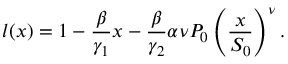<formula> <loc_0><loc_0><loc_500><loc_500>l ( x ) = 1 - \frac { \beta } { \gamma _ { 1 } } x - \frac { \beta } { \gamma _ { 2 } } \alpha \nu P _ { 0 } \left ( \frac { x } { S _ { 0 } } \right ) ^ { \nu } .</formula> 